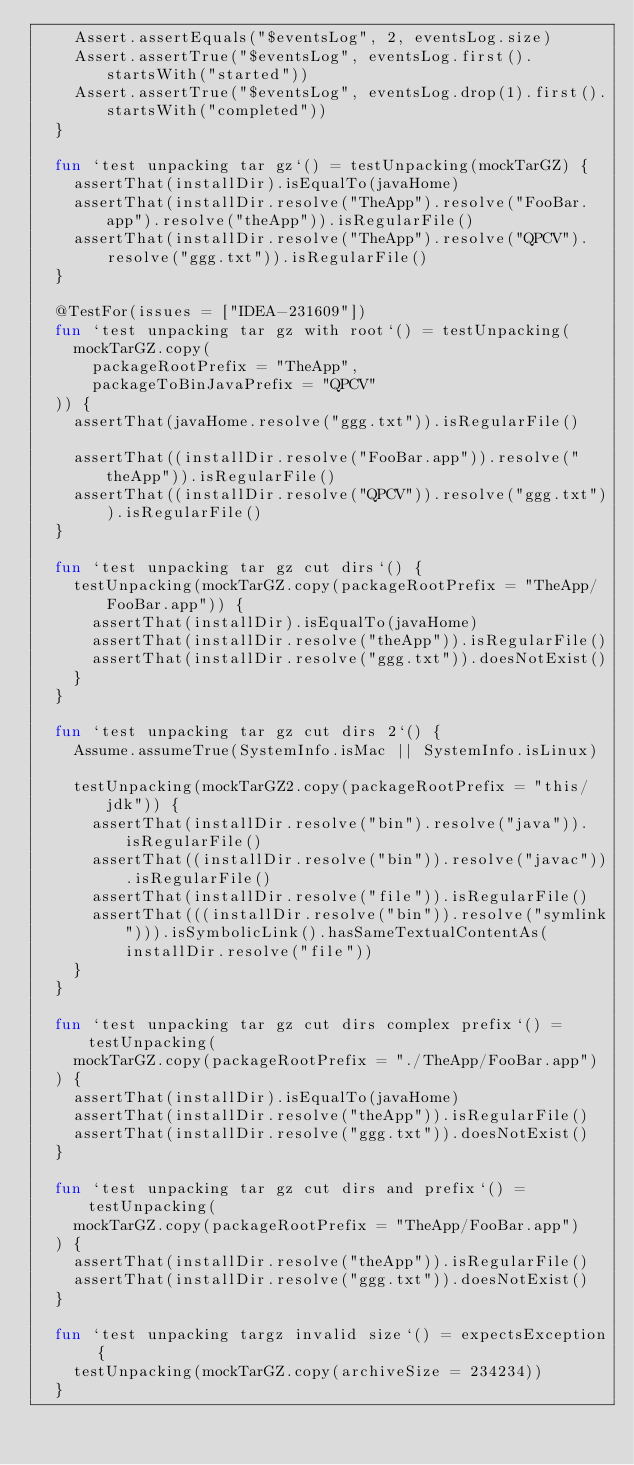<code> <loc_0><loc_0><loc_500><loc_500><_Kotlin_>    Assert.assertEquals("$eventsLog", 2, eventsLog.size)
    Assert.assertTrue("$eventsLog", eventsLog.first().startsWith("started"))
    Assert.assertTrue("$eventsLog", eventsLog.drop(1).first().startsWith("completed"))
  }

  fun `test unpacking tar gz`() = testUnpacking(mockTarGZ) {
    assertThat(installDir).isEqualTo(javaHome)
    assertThat(installDir.resolve("TheApp").resolve("FooBar.app").resolve("theApp")).isRegularFile()
    assertThat(installDir.resolve("TheApp").resolve("QPCV").resolve("ggg.txt")).isRegularFile()
  }

  @TestFor(issues = ["IDEA-231609"])
  fun `test unpacking tar gz with root`() = testUnpacking(
    mockTarGZ.copy(
      packageRootPrefix = "TheApp",
      packageToBinJavaPrefix = "QPCV"
  )) {
    assertThat(javaHome.resolve("ggg.txt")).isRegularFile()

    assertThat((installDir.resolve("FooBar.app")).resolve("theApp")).isRegularFile()
    assertThat((installDir.resolve("QPCV")).resolve("ggg.txt")).isRegularFile()
  }

  fun `test unpacking tar gz cut dirs`() {
    testUnpacking(mockTarGZ.copy(packageRootPrefix = "TheApp/FooBar.app")) {
      assertThat(installDir).isEqualTo(javaHome)
      assertThat(installDir.resolve("theApp")).isRegularFile()
      assertThat(installDir.resolve("ggg.txt")).doesNotExist()
    }
  }

  fun `test unpacking tar gz cut dirs 2`() {
    Assume.assumeTrue(SystemInfo.isMac || SystemInfo.isLinux)

    testUnpacking(mockTarGZ2.copy(packageRootPrefix = "this/jdk")) {
      assertThat(installDir.resolve("bin").resolve("java")).isRegularFile()
      assertThat((installDir.resolve("bin")).resolve("javac")).isRegularFile()
      assertThat(installDir.resolve("file")).isRegularFile()
      assertThat(((installDir.resolve("bin")).resolve("symlink"))).isSymbolicLink().hasSameTextualContentAs(installDir.resolve("file"))
    }
  }

  fun `test unpacking tar gz cut dirs complex prefix`() = testUnpacking(
    mockTarGZ.copy(packageRootPrefix = "./TheApp/FooBar.app")
  ) {
    assertThat(installDir).isEqualTo(javaHome)
    assertThat(installDir.resolve("theApp")).isRegularFile()
    assertThat(installDir.resolve("ggg.txt")).doesNotExist()
  }

  fun `test unpacking tar gz cut dirs and prefix`() = testUnpacking(
    mockTarGZ.copy(packageRootPrefix = "TheApp/FooBar.app")
  ) {
    assertThat(installDir.resolve("theApp")).isRegularFile()
    assertThat(installDir.resolve("ggg.txt")).doesNotExist()
  }

  fun `test unpacking targz invalid size`() = expectsException {
    testUnpacking(mockTarGZ.copy(archiveSize = 234234))
  }
</code> 